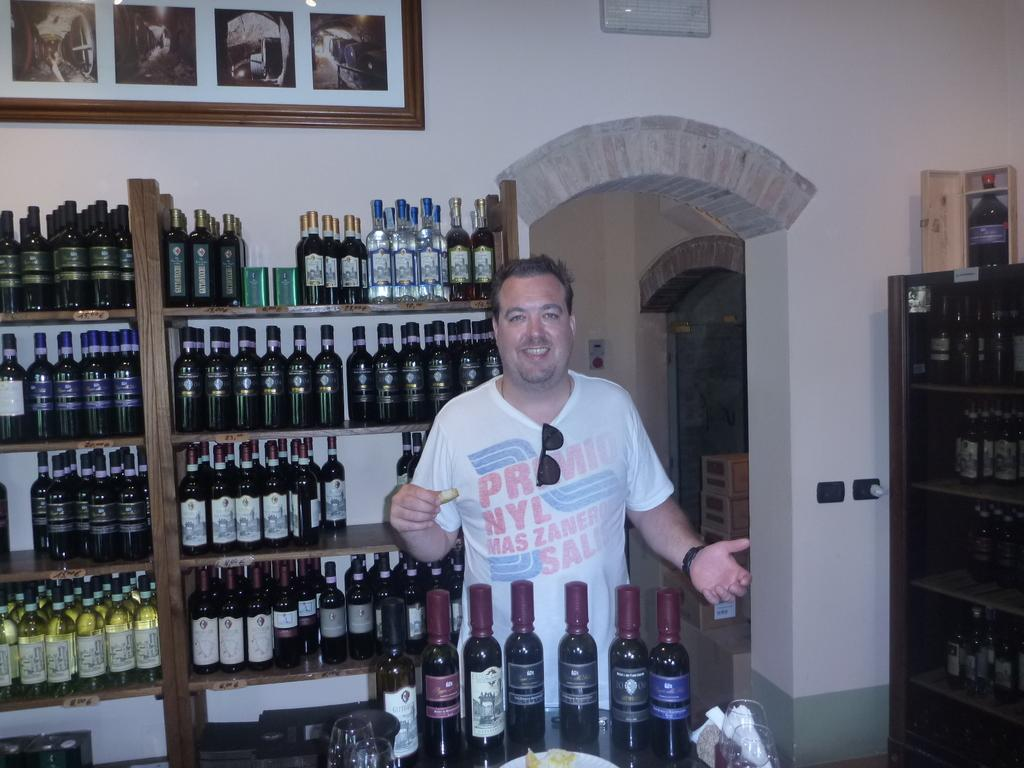Provide a one-sentence caption for the provided image. A man in a shirt that says "primio" at the top has his sunglasses tucked into his collar. 